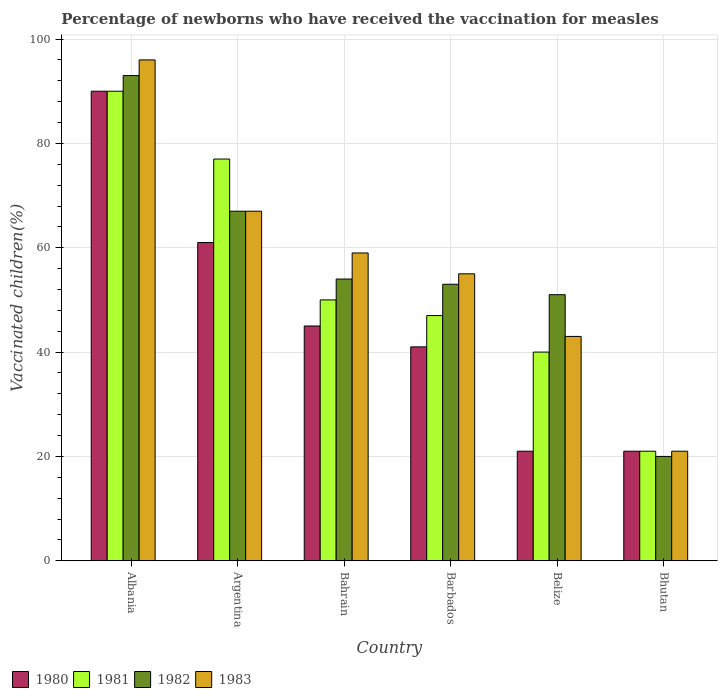Are the number of bars per tick equal to the number of legend labels?
Make the answer very short. Yes. How many bars are there on the 3rd tick from the right?
Your response must be concise. 4. What is the label of the 6th group of bars from the left?
Provide a short and direct response. Bhutan. In how many cases, is the number of bars for a given country not equal to the number of legend labels?
Your response must be concise. 0. Across all countries, what is the maximum percentage of vaccinated children in 1983?
Offer a terse response. 96. In which country was the percentage of vaccinated children in 1980 maximum?
Your answer should be compact. Albania. In which country was the percentage of vaccinated children in 1981 minimum?
Make the answer very short. Bhutan. What is the total percentage of vaccinated children in 1980 in the graph?
Your answer should be compact. 279. What is the difference between the percentage of vaccinated children in 1982 in Albania and that in Argentina?
Offer a terse response. 26. What is the difference between the percentage of vaccinated children in 1982 in Bahrain and the percentage of vaccinated children in 1980 in Argentina?
Offer a very short reply. -7. What is the average percentage of vaccinated children in 1983 per country?
Make the answer very short. 56.83. What is the difference between the percentage of vaccinated children of/in 1983 and percentage of vaccinated children of/in 1980 in Bahrain?
Give a very brief answer. 14. In how many countries, is the percentage of vaccinated children in 1981 greater than 56 %?
Offer a terse response. 2. What is the ratio of the percentage of vaccinated children in 1983 in Albania to that in Barbados?
Offer a very short reply. 1.75. Is the difference between the percentage of vaccinated children in 1983 in Bahrain and Belize greater than the difference between the percentage of vaccinated children in 1980 in Bahrain and Belize?
Provide a short and direct response. No. What is the difference between the highest and the second highest percentage of vaccinated children in 1980?
Give a very brief answer. 45. What is the difference between the highest and the lowest percentage of vaccinated children in 1982?
Provide a succinct answer. 73. Is it the case that in every country, the sum of the percentage of vaccinated children in 1983 and percentage of vaccinated children in 1980 is greater than the sum of percentage of vaccinated children in 1982 and percentage of vaccinated children in 1981?
Offer a terse response. No. What does the 4th bar from the left in Argentina represents?
Your response must be concise. 1983. Is it the case that in every country, the sum of the percentage of vaccinated children in 1981 and percentage of vaccinated children in 1983 is greater than the percentage of vaccinated children in 1980?
Provide a succinct answer. Yes. What is the difference between two consecutive major ticks on the Y-axis?
Provide a short and direct response. 20. Does the graph contain any zero values?
Give a very brief answer. No. Does the graph contain grids?
Provide a short and direct response. Yes. Where does the legend appear in the graph?
Your answer should be very brief. Bottom left. How many legend labels are there?
Offer a terse response. 4. How are the legend labels stacked?
Give a very brief answer. Horizontal. What is the title of the graph?
Your response must be concise. Percentage of newborns who have received the vaccination for measles. What is the label or title of the X-axis?
Ensure brevity in your answer.  Country. What is the label or title of the Y-axis?
Make the answer very short. Vaccinated children(%). What is the Vaccinated children(%) of 1980 in Albania?
Your answer should be compact. 90. What is the Vaccinated children(%) of 1981 in Albania?
Ensure brevity in your answer.  90. What is the Vaccinated children(%) in 1982 in Albania?
Provide a short and direct response. 93. What is the Vaccinated children(%) of 1983 in Albania?
Ensure brevity in your answer.  96. What is the Vaccinated children(%) in 1980 in Argentina?
Your answer should be very brief. 61. What is the Vaccinated children(%) of 1981 in Argentina?
Provide a succinct answer. 77. What is the Vaccinated children(%) of 1982 in Argentina?
Your answer should be very brief. 67. What is the Vaccinated children(%) of 1980 in Bahrain?
Provide a short and direct response. 45. What is the Vaccinated children(%) in 1983 in Bahrain?
Make the answer very short. 59. What is the Vaccinated children(%) of 1980 in Barbados?
Your answer should be very brief. 41. What is the Vaccinated children(%) of 1981 in Barbados?
Give a very brief answer. 47. What is the Vaccinated children(%) in 1982 in Barbados?
Give a very brief answer. 53. What is the Vaccinated children(%) in 1981 in Belize?
Offer a terse response. 40. What is the Vaccinated children(%) in 1982 in Belize?
Keep it short and to the point. 51. What is the Vaccinated children(%) in 1980 in Bhutan?
Make the answer very short. 21. What is the Vaccinated children(%) in 1981 in Bhutan?
Your answer should be compact. 21. What is the Vaccinated children(%) in 1982 in Bhutan?
Your answer should be compact. 20. What is the Vaccinated children(%) in 1983 in Bhutan?
Offer a very short reply. 21. Across all countries, what is the maximum Vaccinated children(%) in 1982?
Give a very brief answer. 93. Across all countries, what is the maximum Vaccinated children(%) of 1983?
Your response must be concise. 96. Across all countries, what is the minimum Vaccinated children(%) in 1981?
Offer a terse response. 21. What is the total Vaccinated children(%) of 1980 in the graph?
Your answer should be very brief. 279. What is the total Vaccinated children(%) in 1981 in the graph?
Make the answer very short. 325. What is the total Vaccinated children(%) in 1982 in the graph?
Offer a terse response. 338. What is the total Vaccinated children(%) in 1983 in the graph?
Offer a terse response. 341. What is the difference between the Vaccinated children(%) of 1982 in Albania and that in Argentina?
Ensure brevity in your answer.  26. What is the difference between the Vaccinated children(%) in 1983 in Albania and that in Argentina?
Your response must be concise. 29. What is the difference between the Vaccinated children(%) of 1982 in Albania and that in Bahrain?
Your answer should be very brief. 39. What is the difference between the Vaccinated children(%) of 1980 in Albania and that in Barbados?
Your answer should be very brief. 49. What is the difference between the Vaccinated children(%) in 1981 in Albania and that in Belize?
Make the answer very short. 50. What is the difference between the Vaccinated children(%) in 1982 in Albania and that in Belize?
Provide a short and direct response. 42. What is the difference between the Vaccinated children(%) of 1983 in Albania and that in Belize?
Provide a short and direct response. 53. What is the difference between the Vaccinated children(%) in 1982 in Albania and that in Bhutan?
Keep it short and to the point. 73. What is the difference between the Vaccinated children(%) of 1980 in Argentina and that in Bahrain?
Ensure brevity in your answer.  16. What is the difference between the Vaccinated children(%) in 1982 in Argentina and that in Bahrain?
Your answer should be compact. 13. What is the difference between the Vaccinated children(%) in 1983 in Argentina and that in Bahrain?
Keep it short and to the point. 8. What is the difference between the Vaccinated children(%) in 1980 in Argentina and that in Barbados?
Keep it short and to the point. 20. What is the difference between the Vaccinated children(%) in 1980 in Argentina and that in Belize?
Ensure brevity in your answer.  40. What is the difference between the Vaccinated children(%) of 1981 in Argentina and that in Belize?
Keep it short and to the point. 37. What is the difference between the Vaccinated children(%) in 1983 in Argentina and that in Bhutan?
Your answer should be very brief. 46. What is the difference between the Vaccinated children(%) of 1982 in Bahrain and that in Barbados?
Ensure brevity in your answer.  1. What is the difference between the Vaccinated children(%) of 1983 in Bahrain and that in Barbados?
Your answer should be very brief. 4. What is the difference between the Vaccinated children(%) in 1983 in Bahrain and that in Belize?
Keep it short and to the point. 16. What is the difference between the Vaccinated children(%) of 1981 in Bahrain and that in Bhutan?
Provide a succinct answer. 29. What is the difference between the Vaccinated children(%) of 1982 in Bahrain and that in Bhutan?
Provide a short and direct response. 34. What is the difference between the Vaccinated children(%) in 1980 in Barbados and that in Belize?
Your answer should be very brief. 20. What is the difference between the Vaccinated children(%) in 1983 in Barbados and that in Belize?
Ensure brevity in your answer.  12. What is the difference between the Vaccinated children(%) in 1980 in Barbados and that in Bhutan?
Provide a short and direct response. 20. What is the difference between the Vaccinated children(%) in 1981 in Barbados and that in Bhutan?
Keep it short and to the point. 26. What is the difference between the Vaccinated children(%) in 1982 in Barbados and that in Bhutan?
Give a very brief answer. 33. What is the difference between the Vaccinated children(%) of 1981 in Belize and that in Bhutan?
Make the answer very short. 19. What is the difference between the Vaccinated children(%) of 1983 in Belize and that in Bhutan?
Your answer should be very brief. 22. What is the difference between the Vaccinated children(%) of 1980 in Albania and the Vaccinated children(%) of 1981 in Argentina?
Give a very brief answer. 13. What is the difference between the Vaccinated children(%) of 1980 in Albania and the Vaccinated children(%) of 1983 in Argentina?
Ensure brevity in your answer.  23. What is the difference between the Vaccinated children(%) of 1982 in Albania and the Vaccinated children(%) of 1983 in Bahrain?
Give a very brief answer. 34. What is the difference between the Vaccinated children(%) of 1980 in Albania and the Vaccinated children(%) of 1983 in Barbados?
Your response must be concise. 35. What is the difference between the Vaccinated children(%) in 1980 in Albania and the Vaccinated children(%) in 1982 in Belize?
Your answer should be compact. 39. What is the difference between the Vaccinated children(%) of 1981 in Albania and the Vaccinated children(%) of 1982 in Belize?
Provide a succinct answer. 39. What is the difference between the Vaccinated children(%) of 1980 in Albania and the Vaccinated children(%) of 1981 in Bhutan?
Offer a terse response. 69. What is the difference between the Vaccinated children(%) of 1980 in Albania and the Vaccinated children(%) of 1983 in Bhutan?
Offer a terse response. 69. What is the difference between the Vaccinated children(%) of 1981 in Albania and the Vaccinated children(%) of 1982 in Bhutan?
Your answer should be very brief. 70. What is the difference between the Vaccinated children(%) in 1982 in Albania and the Vaccinated children(%) in 1983 in Bhutan?
Your response must be concise. 72. What is the difference between the Vaccinated children(%) of 1980 in Argentina and the Vaccinated children(%) of 1981 in Bahrain?
Offer a very short reply. 11. What is the difference between the Vaccinated children(%) of 1980 in Argentina and the Vaccinated children(%) of 1982 in Bahrain?
Give a very brief answer. 7. What is the difference between the Vaccinated children(%) of 1980 in Argentina and the Vaccinated children(%) of 1983 in Bahrain?
Ensure brevity in your answer.  2. What is the difference between the Vaccinated children(%) in 1982 in Argentina and the Vaccinated children(%) in 1983 in Bahrain?
Keep it short and to the point. 8. What is the difference between the Vaccinated children(%) in 1980 in Argentina and the Vaccinated children(%) in 1981 in Barbados?
Ensure brevity in your answer.  14. What is the difference between the Vaccinated children(%) in 1980 in Argentina and the Vaccinated children(%) in 1982 in Barbados?
Offer a terse response. 8. What is the difference between the Vaccinated children(%) of 1980 in Argentina and the Vaccinated children(%) of 1983 in Barbados?
Give a very brief answer. 6. What is the difference between the Vaccinated children(%) in 1980 in Argentina and the Vaccinated children(%) in 1982 in Belize?
Your answer should be very brief. 10. What is the difference between the Vaccinated children(%) in 1981 in Argentina and the Vaccinated children(%) in 1982 in Belize?
Offer a terse response. 26. What is the difference between the Vaccinated children(%) in 1980 in Argentina and the Vaccinated children(%) in 1981 in Bhutan?
Provide a succinct answer. 40. What is the difference between the Vaccinated children(%) in 1980 in Argentina and the Vaccinated children(%) in 1983 in Bhutan?
Give a very brief answer. 40. What is the difference between the Vaccinated children(%) in 1981 in Argentina and the Vaccinated children(%) in 1983 in Bhutan?
Keep it short and to the point. 56. What is the difference between the Vaccinated children(%) of 1980 in Bahrain and the Vaccinated children(%) of 1982 in Barbados?
Offer a terse response. -8. What is the difference between the Vaccinated children(%) of 1981 in Bahrain and the Vaccinated children(%) of 1982 in Barbados?
Ensure brevity in your answer.  -3. What is the difference between the Vaccinated children(%) in 1981 in Bahrain and the Vaccinated children(%) in 1983 in Barbados?
Give a very brief answer. -5. What is the difference between the Vaccinated children(%) of 1982 in Bahrain and the Vaccinated children(%) of 1983 in Barbados?
Provide a succinct answer. -1. What is the difference between the Vaccinated children(%) in 1980 in Bahrain and the Vaccinated children(%) in 1981 in Belize?
Provide a succinct answer. 5. What is the difference between the Vaccinated children(%) of 1980 in Bahrain and the Vaccinated children(%) of 1982 in Belize?
Provide a succinct answer. -6. What is the difference between the Vaccinated children(%) in 1980 in Bahrain and the Vaccinated children(%) in 1983 in Belize?
Your answer should be compact. 2. What is the difference between the Vaccinated children(%) in 1981 in Bahrain and the Vaccinated children(%) in 1982 in Belize?
Provide a succinct answer. -1. What is the difference between the Vaccinated children(%) of 1981 in Bahrain and the Vaccinated children(%) of 1983 in Belize?
Your answer should be compact. 7. What is the difference between the Vaccinated children(%) in 1980 in Bahrain and the Vaccinated children(%) in 1982 in Bhutan?
Ensure brevity in your answer.  25. What is the difference between the Vaccinated children(%) in 1981 in Bahrain and the Vaccinated children(%) in 1982 in Bhutan?
Your answer should be compact. 30. What is the difference between the Vaccinated children(%) in 1982 in Bahrain and the Vaccinated children(%) in 1983 in Bhutan?
Make the answer very short. 33. What is the difference between the Vaccinated children(%) of 1980 in Barbados and the Vaccinated children(%) of 1983 in Belize?
Your answer should be very brief. -2. What is the difference between the Vaccinated children(%) in 1981 in Barbados and the Vaccinated children(%) in 1983 in Bhutan?
Ensure brevity in your answer.  26. What is the difference between the Vaccinated children(%) in 1980 in Belize and the Vaccinated children(%) in 1981 in Bhutan?
Ensure brevity in your answer.  0. What is the difference between the Vaccinated children(%) in 1980 in Belize and the Vaccinated children(%) in 1982 in Bhutan?
Offer a very short reply. 1. What is the difference between the Vaccinated children(%) of 1980 in Belize and the Vaccinated children(%) of 1983 in Bhutan?
Keep it short and to the point. 0. What is the difference between the Vaccinated children(%) of 1981 in Belize and the Vaccinated children(%) of 1982 in Bhutan?
Ensure brevity in your answer.  20. What is the average Vaccinated children(%) in 1980 per country?
Your answer should be compact. 46.5. What is the average Vaccinated children(%) of 1981 per country?
Give a very brief answer. 54.17. What is the average Vaccinated children(%) of 1982 per country?
Give a very brief answer. 56.33. What is the average Vaccinated children(%) in 1983 per country?
Your answer should be very brief. 56.83. What is the difference between the Vaccinated children(%) of 1980 and Vaccinated children(%) of 1982 in Albania?
Keep it short and to the point. -3. What is the difference between the Vaccinated children(%) in 1981 and Vaccinated children(%) in 1982 in Albania?
Ensure brevity in your answer.  -3. What is the difference between the Vaccinated children(%) in 1981 and Vaccinated children(%) in 1983 in Albania?
Ensure brevity in your answer.  -6. What is the difference between the Vaccinated children(%) of 1980 and Vaccinated children(%) of 1981 in Argentina?
Your response must be concise. -16. What is the difference between the Vaccinated children(%) of 1980 and Vaccinated children(%) of 1983 in Argentina?
Provide a succinct answer. -6. What is the difference between the Vaccinated children(%) of 1981 and Vaccinated children(%) of 1982 in Argentina?
Your answer should be compact. 10. What is the difference between the Vaccinated children(%) of 1982 and Vaccinated children(%) of 1983 in Argentina?
Offer a very short reply. 0. What is the difference between the Vaccinated children(%) in 1980 and Vaccinated children(%) in 1981 in Bahrain?
Offer a terse response. -5. What is the difference between the Vaccinated children(%) of 1980 and Vaccinated children(%) of 1982 in Bahrain?
Your response must be concise. -9. What is the difference between the Vaccinated children(%) of 1982 and Vaccinated children(%) of 1983 in Bahrain?
Keep it short and to the point. -5. What is the difference between the Vaccinated children(%) in 1980 and Vaccinated children(%) in 1981 in Belize?
Give a very brief answer. -19. What is the difference between the Vaccinated children(%) in 1980 and Vaccinated children(%) in 1983 in Belize?
Give a very brief answer. -22. What is the difference between the Vaccinated children(%) in 1981 and Vaccinated children(%) in 1982 in Belize?
Offer a very short reply. -11. What is the difference between the Vaccinated children(%) of 1981 and Vaccinated children(%) of 1983 in Belize?
Keep it short and to the point. -3. What is the ratio of the Vaccinated children(%) of 1980 in Albania to that in Argentina?
Keep it short and to the point. 1.48. What is the ratio of the Vaccinated children(%) in 1981 in Albania to that in Argentina?
Your response must be concise. 1.17. What is the ratio of the Vaccinated children(%) of 1982 in Albania to that in Argentina?
Your answer should be very brief. 1.39. What is the ratio of the Vaccinated children(%) in 1983 in Albania to that in Argentina?
Provide a succinct answer. 1.43. What is the ratio of the Vaccinated children(%) in 1980 in Albania to that in Bahrain?
Provide a short and direct response. 2. What is the ratio of the Vaccinated children(%) in 1982 in Albania to that in Bahrain?
Your answer should be very brief. 1.72. What is the ratio of the Vaccinated children(%) in 1983 in Albania to that in Bahrain?
Your answer should be compact. 1.63. What is the ratio of the Vaccinated children(%) in 1980 in Albania to that in Barbados?
Your answer should be very brief. 2.2. What is the ratio of the Vaccinated children(%) in 1981 in Albania to that in Barbados?
Your answer should be compact. 1.91. What is the ratio of the Vaccinated children(%) of 1982 in Albania to that in Barbados?
Your response must be concise. 1.75. What is the ratio of the Vaccinated children(%) of 1983 in Albania to that in Barbados?
Provide a short and direct response. 1.75. What is the ratio of the Vaccinated children(%) of 1980 in Albania to that in Belize?
Keep it short and to the point. 4.29. What is the ratio of the Vaccinated children(%) of 1981 in Albania to that in Belize?
Your answer should be very brief. 2.25. What is the ratio of the Vaccinated children(%) in 1982 in Albania to that in Belize?
Your answer should be very brief. 1.82. What is the ratio of the Vaccinated children(%) in 1983 in Albania to that in Belize?
Provide a succinct answer. 2.23. What is the ratio of the Vaccinated children(%) in 1980 in Albania to that in Bhutan?
Your response must be concise. 4.29. What is the ratio of the Vaccinated children(%) in 1981 in Albania to that in Bhutan?
Offer a very short reply. 4.29. What is the ratio of the Vaccinated children(%) of 1982 in Albania to that in Bhutan?
Your answer should be compact. 4.65. What is the ratio of the Vaccinated children(%) of 1983 in Albania to that in Bhutan?
Your answer should be compact. 4.57. What is the ratio of the Vaccinated children(%) in 1980 in Argentina to that in Bahrain?
Your answer should be very brief. 1.36. What is the ratio of the Vaccinated children(%) in 1981 in Argentina to that in Bahrain?
Provide a succinct answer. 1.54. What is the ratio of the Vaccinated children(%) of 1982 in Argentina to that in Bahrain?
Give a very brief answer. 1.24. What is the ratio of the Vaccinated children(%) of 1983 in Argentina to that in Bahrain?
Offer a terse response. 1.14. What is the ratio of the Vaccinated children(%) of 1980 in Argentina to that in Barbados?
Your response must be concise. 1.49. What is the ratio of the Vaccinated children(%) in 1981 in Argentina to that in Barbados?
Your answer should be very brief. 1.64. What is the ratio of the Vaccinated children(%) in 1982 in Argentina to that in Barbados?
Your response must be concise. 1.26. What is the ratio of the Vaccinated children(%) in 1983 in Argentina to that in Barbados?
Offer a very short reply. 1.22. What is the ratio of the Vaccinated children(%) of 1980 in Argentina to that in Belize?
Your answer should be compact. 2.9. What is the ratio of the Vaccinated children(%) of 1981 in Argentina to that in Belize?
Your response must be concise. 1.93. What is the ratio of the Vaccinated children(%) of 1982 in Argentina to that in Belize?
Provide a succinct answer. 1.31. What is the ratio of the Vaccinated children(%) of 1983 in Argentina to that in Belize?
Offer a terse response. 1.56. What is the ratio of the Vaccinated children(%) of 1980 in Argentina to that in Bhutan?
Ensure brevity in your answer.  2.9. What is the ratio of the Vaccinated children(%) of 1981 in Argentina to that in Bhutan?
Your answer should be very brief. 3.67. What is the ratio of the Vaccinated children(%) in 1982 in Argentina to that in Bhutan?
Keep it short and to the point. 3.35. What is the ratio of the Vaccinated children(%) of 1983 in Argentina to that in Bhutan?
Your response must be concise. 3.19. What is the ratio of the Vaccinated children(%) in 1980 in Bahrain to that in Barbados?
Your answer should be very brief. 1.1. What is the ratio of the Vaccinated children(%) in 1981 in Bahrain to that in Barbados?
Your response must be concise. 1.06. What is the ratio of the Vaccinated children(%) in 1982 in Bahrain to that in Barbados?
Make the answer very short. 1.02. What is the ratio of the Vaccinated children(%) of 1983 in Bahrain to that in Barbados?
Your answer should be compact. 1.07. What is the ratio of the Vaccinated children(%) of 1980 in Bahrain to that in Belize?
Keep it short and to the point. 2.14. What is the ratio of the Vaccinated children(%) in 1982 in Bahrain to that in Belize?
Make the answer very short. 1.06. What is the ratio of the Vaccinated children(%) of 1983 in Bahrain to that in Belize?
Ensure brevity in your answer.  1.37. What is the ratio of the Vaccinated children(%) of 1980 in Bahrain to that in Bhutan?
Your response must be concise. 2.14. What is the ratio of the Vaccinated children(%) in 1981 in Bahrain to that in Bhutan?
Your answer should be very brief. 2.38. What is the ratio of the Vaccinated children(%) of 1982 in Bahrain to that in Bhutan?
Your response must be concise. 2.7. What is the ratio of the Vaccinated children(%) in 1983 in Bahrain to that in Bhutan?
Your answer should be compact. 2.81. What is the ratio of the Vaccinated children(%) in 1980 in Barbados to that in Belize?
Your response must be concise. 1.95. What is the ratio of the Vaccinated children(%) of 1981 in Barbados to that in Belize?
Keep it short and to the point. 1.18. What is the ratio of the Vaccinated children(%) of 1982 in Barbados to that in Belize?
Offer a very short reply. 1.04. What is the ratio of the Vaccinated children(%) of 1983 in Barbados to that in Belize?
Keep it short and to the point. 1.28. What is the ratio of the Vaccinated children(%) of 1980 in Barbados to that in Bhutan?
Provide a succinct answer. 1.95. What is the ratio of the Vaccinated children(%) of 1981 in Barbados to that in Bhutan?
Provide a short and direct response. 2.24. What is the ratio of the Vaccinated children(%) of 1982 in Barbados to that in Bhutan?
Your response must be concise. 2.65. What is the ratio of the Vaccinated children(%) of 1983 in Barbados to that in Bhutan?
Provide a short and direct response. 2.62. What is the ratio of the Vaccinated children(%) of 1981 in Belize to that in Bhutan?
Offer a very short reply. 1.9. What is the ratio of the Vaccinated children(%) of 1982 in Belize to that in Bhutan?
Offer a terse response. 2.55. What is the ratio of the Vaccinated children(%) of 1983 in Belize to that in Bhutan?
Your response must be concise. 2.05. What is the difference between the highest and the second highest Vaccinated children(%) of 1982?
Offer a terse response. 26. What is the difference between the highest and the lowest Vaccinated children(%) in 1981?
Offer a very short reply. 69. What is the difference between the highest and the lowest Vaccinated children(%) of 1982?
Offer a terse response. 73. 